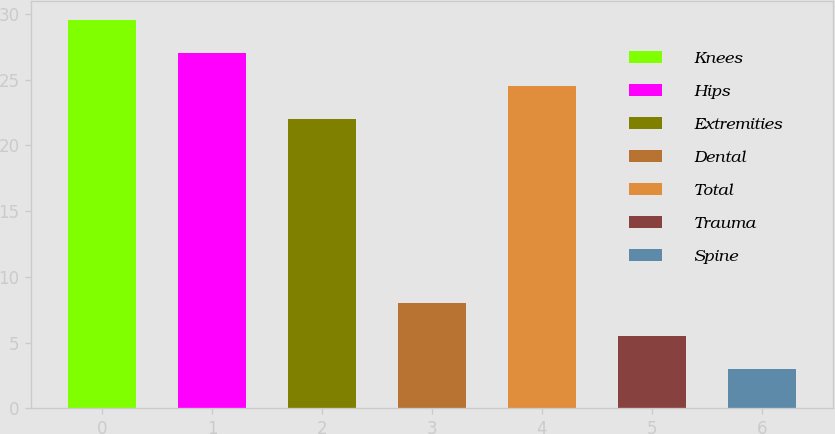Convert chart. <chart><loc_0><loc_0><loc_500><loc_500><bar_chart><fcel>Knees<fcel>Hips<fcel>Extremities<fcel>Dental<fcel>Total<fcel>Trauma<fcel>Spine<nl><fcel>29.5<fcel>27<fcel>22<fcel>8<fcel>24.5<fcel>5.5<fcel>3<nl></chart> 